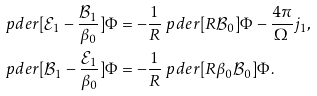Convert formula to latex. <formula><loc_0><loc_0><loc_500><loc_500>\ p d e r [ \mathcal { E } _ { 1 } - \frac { \mathcal { B } _ { 1 } } { \beta _ { 0 } } ] { \Phi } & = - \frac { 1 } { R } \ p d e r [ R \mathcal { B } _ { 0 } ] { \Phi } - \frac { 4 \pi } { \Omega } j _ { 1 } , \\ \ p d e r [ \mathcal { B } _ { 1 } - \frac { \mathcal { E } _ { 1 } } { \beta _ { 0 } } ] { \Phi } & = - \frac { 1 } { R } \ p d e r [ R \beta _ { 0 } \mathcal { B } _ { 0 } ] { \Phi } .</formula> 